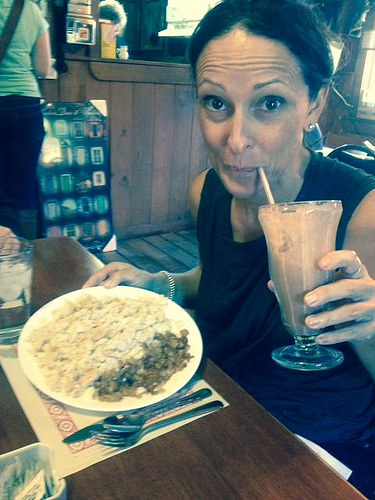<image>
Is there a glass to the right of the plate? Yes. From this viewpoint, the glass is positioned to the right side relative to the plate. 